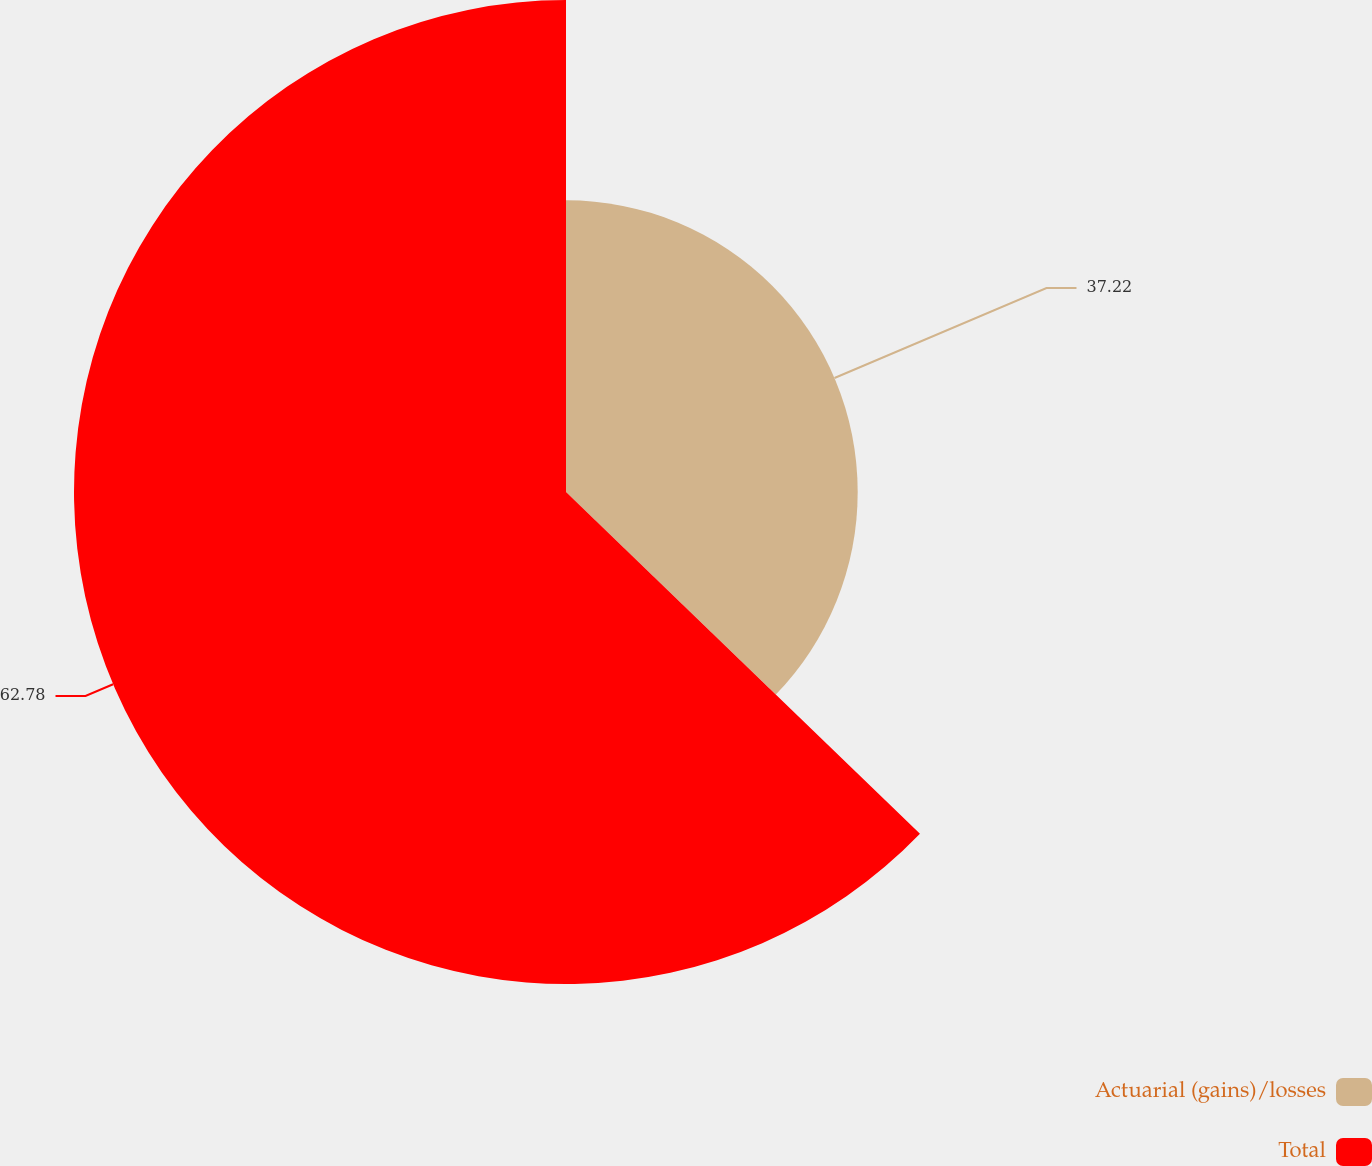<chart> <loc_0><loc_0><loc_500><loc_500><pie_chart><fcel>Actuarial (gains)/losses<fcel>Total<nl><fcel>37.22%<fcel>62.78%<nl></chart> 